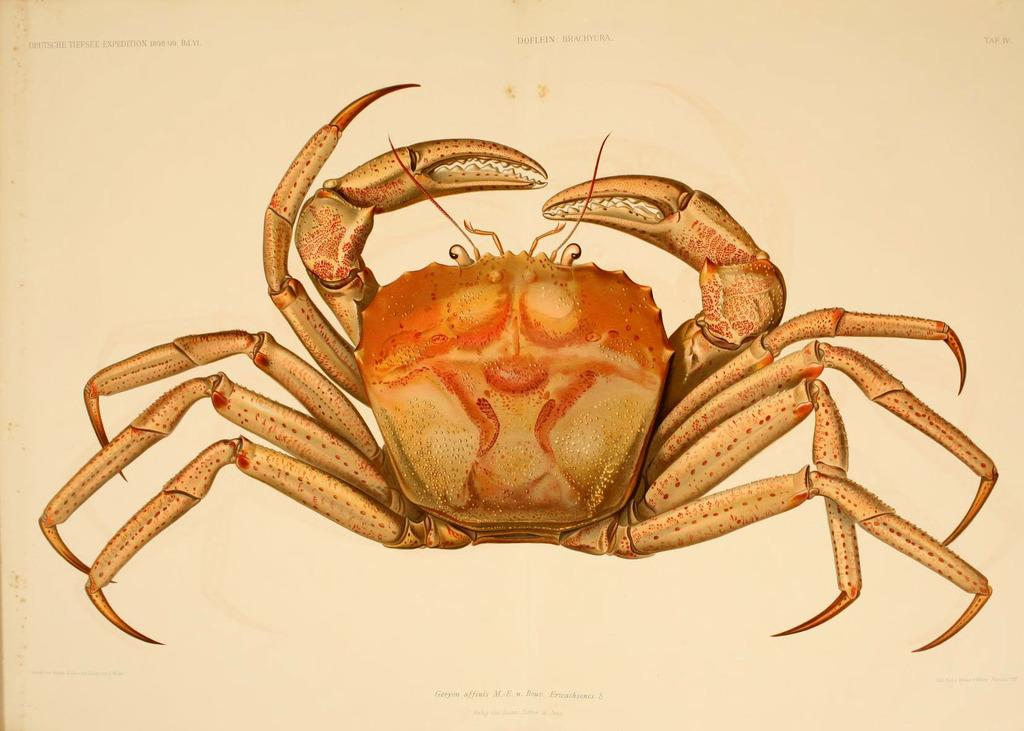What type of art is depicted in the image? There is crab art in the image. How many bikes are parked next to the crab art in the image? There is no information about bikes in the image, as it only mentions crab art. 